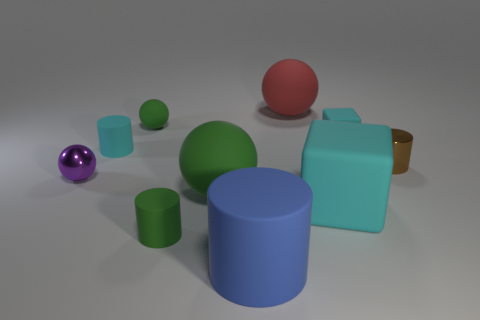What number of small metal objects are there?
Keep it short and to the point. 2. There is a small sphere that is in front of the cylinder to the right of the big cylinder; what is its material?
Your answer should be compact. Metal. What is the color of the tiny matte object in front of the large cyan matte thing that is on the right side of the small matte cylinder that is behind the big green matte thing?
Provide a short and direct response. Green. Is the small matte cube the same color as the large rubber block?
Offer a terse response. Yes. What number of other shiny cylinders have the same size as the blue cylinder?
Make the answer very short. 0. Are there more big objects behind the small brown object than large red things that are left of the big green rubber ball?
Offer a very short reply. Yes. What is the color of the tiny object that is behind the matte block that is right of the big cyan matte thing?
Your response must be concise. Green. Does the purple sphere have the same material as the small brown cylinder?
Your response must be concise. Yes. Are there any other rubber objects that have the same shape as the large blue object?
Provide a short and direct response. Yes. Does the tiny matte cylinder that is in front of the tiny purple shiny sphere have the same color as the tiny matte ball?
Your answer should be very brief. Yes. 